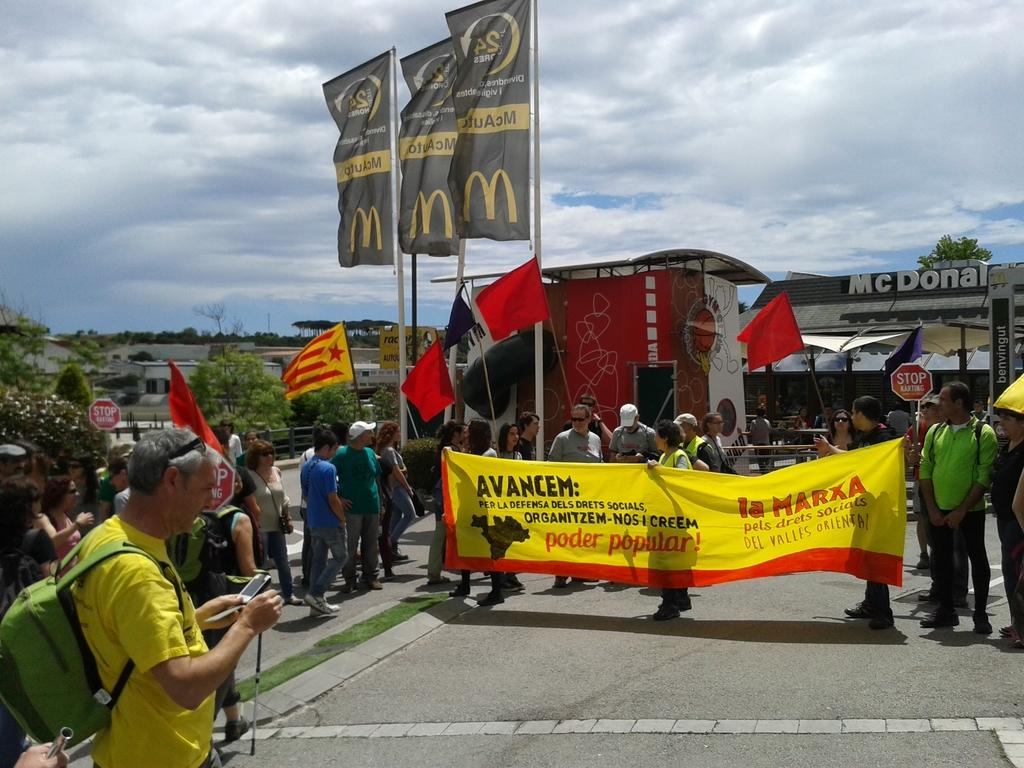<image>
Create a compact narrative representing the image presented. People walk carrying an AVANCEM banner that is yellow. 